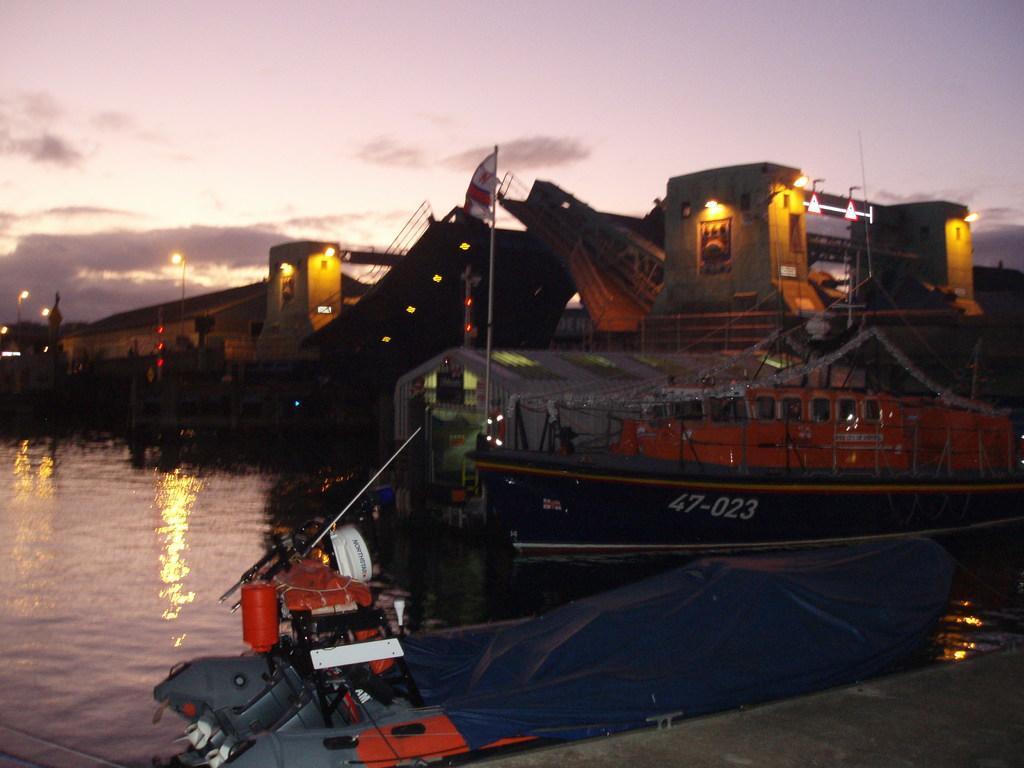Describe this image in one or two sentences. In this picture there are two boats on the water and there are few buildings,lights and some other objects in the background. 